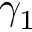<formula> <loc_0><loc_0><loc_500><loc_500>\gamma _ { 1 }</formula> 